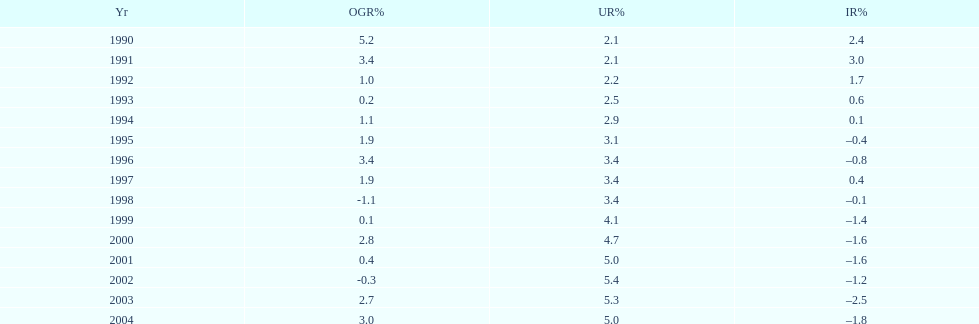In what years, between 1990 and 2004, did japan's unemployment rate reach 5% or higher? 4. 